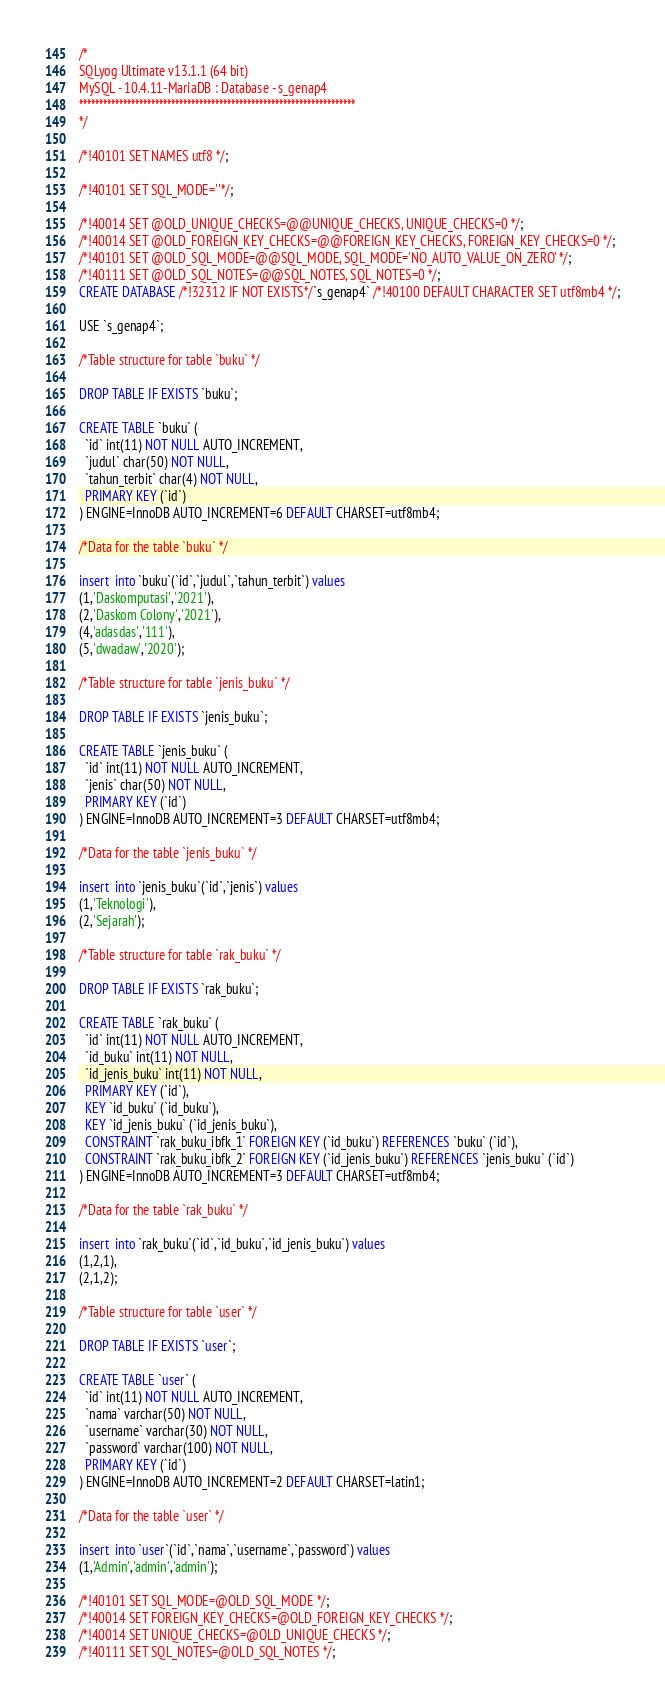<code> <loc_0><loc_0><loc_500><loc_500><_SQL_>/*
SQLyog Ultimate v13.1.1 (64 bit)
MySQL - 10.4.11-MariaDB : Database - s_genap4
*********************************************************************
*/

/*!40101 SET NAMES utf8 */;

/*!40101 SET SQL_MODE=''*/;

/*!40014 SET @OLD_UNIQUE_CHECKS=@@UNIQUE_CHECKS, UNIQUE_CHECKS=0 */;
/*!40014 SET @OLD_FOREIGN_KEY_CHECKS=@@FOREIGN_KEY_CHECKS, FOREIGN_KEY_CHECKS=0 */;
/*!40101 SET @OLD_SQL_MODE=@@SQL_MODE, SQL_MODE='NO_AUTO_VALUE_ON_ZERO' */;
/*!40111 SET @OLD_SQL_NOTES=@@SQL_NOTES, SQL_NOTES=0 */;
CREATE DATABASE /*!32312 IF NOT EXISTS*/`s_genap4` /*!40100 DEFAULT CHARACTER SET utf8mb4 */;

USE `s_genap4`;

/*Table structure for table `buku` */

DROP TABLE IF EXISTS `buku`;

CREATE TABLE `buku` (
  `id` int(11) NOT NULL AUTO_INCREMENT,
  `judul` char(50) NOT NULL,
  `tahun_terbit` char(4) NOT NULL,
  PRIMARY KEY (`id`)
) ENGINE=InnoDB AUTO_INCREMENT=6 DEFAULT CHARSET=utf8mb4;

/*Data for the table `buku` */

insert  into `buku`(`id`,`judul`,`tahun_terbit`) values 
(1,'Daskomputasi','2021'),
(2,'Daskom Colony','2021'),
(4,'adasdas','111'),
(5,'dwadaw','2020');

/*Table structure for table `jenis_buku` */

DROP TABLE IF EXISTS `jenis_buku`;

CREATE TABLE `jenis_buku` (
  `id` int(11) NOT NULL AUTO_INCREMENT,
  `jenis` char(50) NOT NULL,
  PRIMARY KEY (`id`)
) ENGINE=InnoDB AUTO_INCREMENT=3 DEFAULT CHARSET=utf8mb4;

/*Data for the table `jenis_buku` */

insert  into `jenis_buku`(`id`,`jenis`) values 
(1,'Teknologi'),
(2,'Sejarah');

/*Table structure for table `rak_buku` */

DROP TABLE IF EXISTS `rak_buku`;

CREATE TABLE `rak_buku` (
  `id` int(11) NOT NULL AUTO_INCREMENT,
  `id_buku` int(11) NOT NULL,
  `id_jenis_buku` int(11) NOT NULL,
  PRIMARY KEY (`id`),
  KEY `id_buku` (`id_buku`),
  KEY `id_jenis_buku` (`id_jenis_buku`),
  CONSTRAINT `rak_buku_ibfk_1` FOREIGN KEY (`id_buku`) REFERENCES `buku` (`id`),
  CONSTRAINT `rak_buku_ibfk_2` FOREIGN KEY (`id_jenis_buku`) REFERENCES `jenis_buku` (`id`)
) ENGINE=InnoDB AUTO_INCREMENT=3 DEFAULT CHARSET=utf8mb4;

/*Data for the table `rak_buku` */

insert  into `rak_buku`(`id`,`id_buku`,`id_jenis_buku`) values 
(1,2,1),
(2,1,2);

/*Table structure for table `user` */

DROP TABLE IF EXISTS `user`;

CREATE TABLE `user` (
  `id` int(11) NOT NULL AUTO_INCREMENT,
  `nama` varchar(50) NOT NULL,
  `username` varchar(30) NOT NULL,
  `password` varchar(100) NOT NULL,
  PRIMARY KEY (`id`)
) ENGINE=InnoDB AUTO_INCREMENT=2 DEFAULT CHARSET=latin1;

/*Data for the table `user` */

insert  into `user`(`id`,`nama`,`username`,`password`) values 
(1,'Admin','admin','admin');

/*!40101 SET SQL_MODE=@OLD_SQL_MODE */;
/*!40014 SET FOREIGN_KEY_CHECKS=@OLD_FOREIGN_KEY_CHECKS */;
/*!40014 SET UNIQUE_CHECKS=@OLD_UNIQUE_CHECKS */;
/*!40111 SET SQL_NOTES=@OLD_SQL_NOTES */;
</code> 